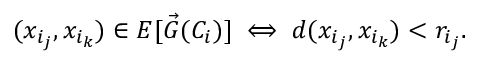<formula> <loc_0><loc_0><loc_500><loc_500>( x _ { i _ { j } } , x _ { i _ { k } } ) \in E [ \vec { G } ( C _ { i } ) ] \iff d ( x _ { i _ { j } } , x _ { i _ { k } } ) < r _ { i _ { j } } .</formula> 